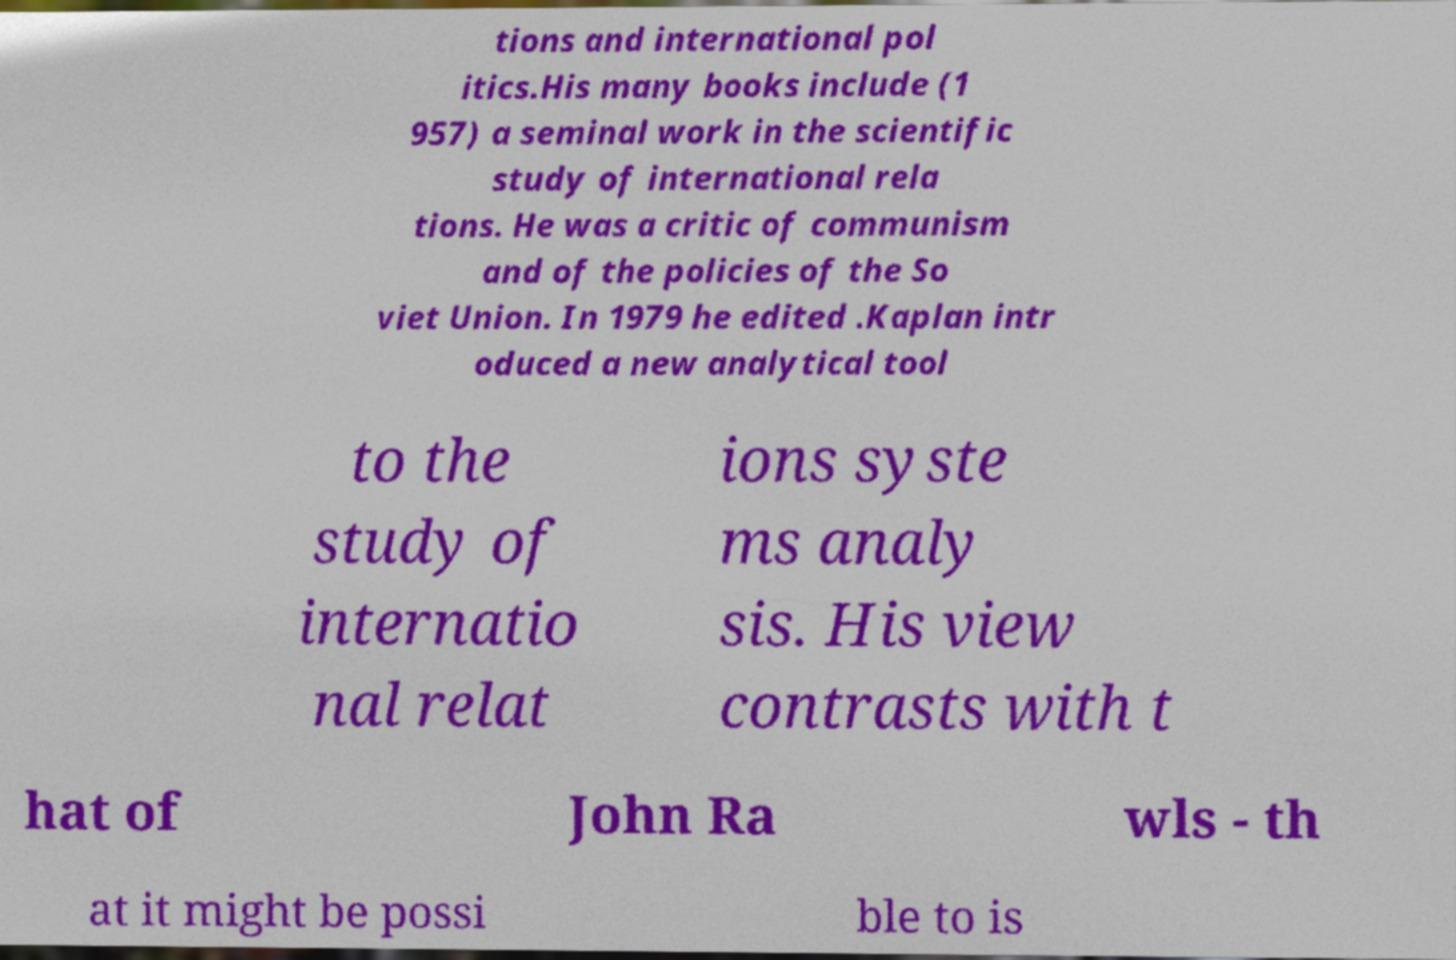Please read and relay the text visible in this image. What does it say? tions and international pol itics.His many books include (1 957) a seminal work in the scientific study of international rela tions. He was a critic of communism and of the policies of the So viet Union. In 1979 he edited .Kaplan intr oduced a new analytical tool to the study of internatio nal relat ions syste ms analy sis. His view contrasts with t hat of John Ra wls - th at it might be possi ble to is 